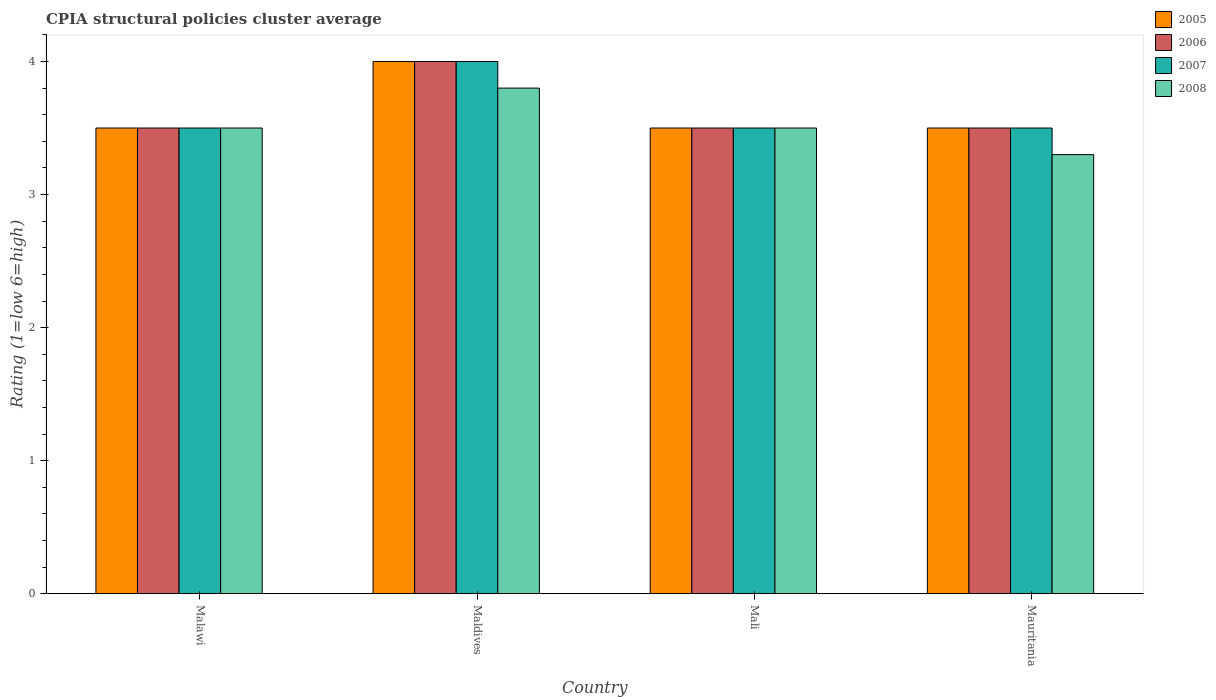How many different coloured bars are there?
Offer a terse response. 4. How many bars are there on the 3rd tick from the left?
Offer a very short reply. 4. How many bars are there on the 3rd tick from the right?
Ensure brevity in your answer.  4. What is the label of the 2nd group of bars from the left?
Offer a very short reply. Maldives. Across all countries, what is the minimum CPIA rating in 2008?
Your response must be concise. 3.3. In which country was the CPIA rating in 2006 maximum?
Provide a short and direct response. Maldives. In which country was the CPIA rating in 2005 minimum?
Offer a very short reply. Malawi. What is the total CPIA rating in 2008 in the graph?
Give a very brief answer. 14.1. What is the difference between the CPIA rating in 2008 in Malawi and that in Mauritania?
Provide a succinct answer. 0.2. What is the difference between the CPIA rating in 2005 in Maldives and the CPIA rating in 2006 in Mauritania?
Offer a very short reply. 0.5. What is the average CPIA rating in 2005 per country?
Keep it short and to the point. 3.62. What is the difference between the CPIA rating of/in 2008 and CPIA rating of/in 2005 in Maldives?
Keep it short and to the point. -0.2. What is the ratio of the CPIA rating in 2005 in Maldives to that in Mauritania?
Your answer should be compact. 1.14. Is the difference between the CPIA rating in 2008 in Maldives and Mauritania greater than the difference between the CPIA rating in 2005 in Maldives and Mauritania?
Make the answer very short. No. What is the difference between the highest and the second highest CPIA rating in 2007?
Provide a succinct answer. -0.5. In how many countries, is the CPIA rating in 2007 greater than the average CPIA rating in 2007 taken over all countries?
Your response must be concise. 1. Is the sum of the CPIA rating in 2008 in Maldives and Mauritania greater than the maximum CPIA rating in 2006 across all countries?
Ensure brevity in your answer.  Yes. Is it the case that in every country, the sum of the CPIA rating in 2006 and CPIA rating in 2005 is greater than the sum of CPIA rating in 2007 and CPIA rating in 2008?
Make the answer very short. No. What does the 2nd bar from the left in Mauritania represents?
Your answer should be very brief. 2006. What does the 2nd bar from the right in Maldives represents?
Keep it short and to the point. 2007. How many countries are there in the graph?
Provide a succinct answer. 4. What is the difference between two consecutive major ticks on the Y-axis?
Your answer should be compact. 1. Are the values on the major ticks of Y-axis written in scientific E-notation?
Provide a short and direct response. No. How many legend labels are there?
Your answer should be very brief. 4. How are the legend labels stacked?
Keep it short and to the point. Vertical. What is the title of the graph?
Provide a short and direct response. CPIA structural policies cluster average. What is the label or title of the X-axis?
Your answer should be compact. Country. What is the label or title of the Y-axis?
Your answer should be compact. Rating (1=low 6=high). What is the Rating (1=low 6=high) of 2005 in Malawi?
Keep it short and to the point. 3.5. What is the Rating (1=low 6=high) of 2007 in Malawi?
Your answer should be very brief. 3.5. What is the Rating (1=low 6=high) of 2008 in Malawi?
Provide a succinct answer. 3.5. What is the Rating (1=low 6=high) in 2005 in Maldives?
Offer a very short reply. 4. What is the Rating (1=low 6=high) of 2006 in Maldives?
Provide a succinct answer. 4. What is the Rating (1=low 6=high) in 2007 in Maldives?
Your answer should be compact. 4. What is the Rating (1=low 6=high) of 2006 in Mali?
Offer a terse response. 3.5. What is the Rating (1=low 6=high) in 2006 in Mauritania?
Your answer should be very brief. 3.5. Across all countries, what is the maximum Rating (1=low 6=high) in 2005?
Provide a short and direct response. 4. Across all countries, what is the minimum Rating (1=low 6=high) in 2008?
Keep it short and to the point. 3.3. What is the total Rating (1=low 6=high) of 2005 in the graph?
Keep it short and to the point. 14.5. What is the total Rating (1=low 6=high) of 2006 in the graph?
Provide a short and direct response. 14.5. What is the difference between the Rating (1=low 6=high) in 2006 in Malawi and that in Maldives?
Your answer should be very brief. -0.5. What is the difference between the Rating (1=low 6=high) in 2008 in Malawi and that in Maldives?
Your answer should be compact. -0.3. What is the difference between the Rating (1=low 6=high) in 2006 in Malawi and that in Mauritania?
Offer a very short reply. 0. What is the difference between the Rating (1=low 6=high) of 2007 in Maldives and that in Mali?
Make the answer very short. 0.5. What is the difference between the Rating (1=low 6=high) in 2005 in Maldives and that in Mauritania?
Give a very brief answer. 0.5. What is the difference between the Rating (1=low 6=high) of 2007 in Maldives and that in Mauritania?
Provide a short and direct response. 0.5. What is the difference between the Rating (1=low 6=high) in 2005 in Mali and that in Mauritania?
Your answer should be very brief. 0. What is the difference between the Rating (1=low 6=high) in 2008 in Mali and that in Mauritania?
Your response must be concise. 0.2. What is the difference between the Rating (1=low 6=high) in 2006 in Malawi and the Rating (1=low 6=high) in 2008 in Maldives?
Your response must be concise. -0.3. What is the difference between the Rating (1=low 6=high) in 2007 in Malawi and the Rating (1=low 6=high) in 2008 in Maldives?
Your answer should be very brief. -0.3. What is the difference between the Rating (1=low 6=high) of 2005 in Malawi and the Rating (1=low 6=high) of 2008 in Mali?
Your answer should be compact. 0. What is the difference between the Rating (1=low 6=high) in 2006 in Malawi and the Rating (1=low 6=high) in 2008 in Mali?
Give a very brief answer. 0. What is the difference between the Rating (1=low 6=high) of 2007 in Malawi and the Rating (1=low 6=high) of 2008 in Mali?
Your answer should be compact. 0. What is the difference between the Rating (1=low 6=high) in 2005 in Malawi and the Rating (1=low 6=high) in 2006 in Mauritania?
Provide a short and direct response. 0. What is the difference between the Rating (1=low 6=high) of 2006 in Malawi and the Rating (1=low 6=high) of 2007 in Mauritania?
Keep it short and to the point. 0. What is the difference between the Rating (1=low 6=high) of 2006 in Malawi and the Rating (1=low 6=high) of 2008 in Mauritania?
Provide a short and direct response. 0.2. What is the difference between the Rating (1=low 6=high) of 2005 in Maldives and the Rating (1=low 6=high) of 2006 in Mali?
Offer a very short reply. 0.5. What is the difference between the Rating (1=low 6=high) of 2005 in Maldives and the Rating (1=low 6=high) of 2007 in Mali?
Make the answer very short. 0.5. What is the difference between the Rating (1=low 6=high) in 2005 in Maldives and the Rating (1=low 6=high) in 2008 in Mali?
Offer a terse response. 0.5. What is the difference between the Rating (1=low 6=high) in 2006 in Maldives and the Rating (1=low 6=high) in 2007 in Mali?
Your response must be concise. 0.5. What is the difference between the Rating (1=low 6=high) in 2005 in Maldives and the Rating (1=low 6=high) in 2006 in Mauritania?
Offer a terse response. 0.5. What is the difference between the Rating (1=low 6=high) of 2005 in Maldives and the Rating (1=low 6=high) of 2008 in Mauritania?
Provide a succinct answer. 0.7. What is the difference between the Rating (1=low 6=high) in 2006 in Maldives and the Rating (1=low 6=high) in 2007 in Mauritania?
Provide a short and direct response. 0.5. What is the difference between the Rating (1=low 6=high) of 2007 in Maldives and the Rating (1=low 6=high) of 2008 in Mauritania?
Your answer should be very brief. 0.7. What is the difference between the Rating (1=low 6=high) in 2007 in Mali and the Rating (1=low 6=high) in 2008 in Mauritania?
Your answer should be compact. 0.2. What is the average Rating (1=low 6=high) in 2005 per country?
Offer a terse response. 3.62. What is the average Rating (1=low 6=high) of 2006 per country?
Your answer should be compact. 3.62. What is the average Rating (1=low 6=high) in 2007 per country?
Offer a terse response. 3.62. What is the average Rating (1=low 6=high) in 2008 per country?
Keep it short and to the point. 3.52. What is the difference between the Rating (1=low 6=high) in 2005 and Rating (1=low 6=high) in 2006 in Malawi?
Provide a short and direct response. 0. What is the difference between the Rating (1=low 6=high) of 2005 and Rating (1=low 6=high) of 2007 in Malawi?
Keep it short and to the point. 0. What is the difference between the Rating (1=low 6=high) in 2006 and Rating (1=low 6=high) in 2007 in Malawi?
Provide a short and direct response. 0. What is the difference between the Rating (1=low 6=high) in 2007 and Rating (1=low 6=high) in 2008 in Malawi?
Ensure brevity in your answer.  0. What is the difference between the Rating (1=low 6=high) of 2005 and Rating (1=low 6=high) of 2006 in Maldives?
Give a very brief answer. 0. What is the difference between the Rating (1=low 6=high) in 2005 and Rating (1=low 6=high) in 2007 in Maldives?
Provide a short and direct response. 0. What is the difference between the Rating (1=low 6=high) in 2005 and Rating (1=low 6=high) in 2008 in Maldives?
Your answer should be compact. 0.2. What is the difference between the Rating (1=low 6=high) of 2006 and Rating (1=low 6=high) of 2007 in Maldives?
Ensure brevity in your answer.  0. What is the difference between the Rating (1=low 6=high) of 2005 and Rating (1=low 6=high) of 2006 in Mali?
Keep it short and to the point. 0. What is the difference between the Rating (1=low 6=high) in 2005 and Rating (1=low 6=high) in 2007 in Mali?
Your answer should be very brief. 0. What is the difference between the Rating (1=low 6=high) of 2007 and Rating (1=low 6=high) of 2008 in Mali?
Give a very brief answer. 0. What is the difference between the Rating (1=low 6=high) in 2005 and Rating (1=low 6=high) in 2006 in Mauritania?
Provide a succinct answer. 0. What is the difference between the Rating (1=low 6=high) in 2005 and Rating (1=low 6=high) in 2007 in Mauritania?
Offer a terse response. 0. What is the difference between the Rating (1=low 6=high) of 2005 and Rating (1=low 6=high) of 2008 in Mauritania?
Provide a short and direct response. 0.2. What is the difference between the Rating (1=low 6=high) in 2006 and Rating (1=low 6=high) in 2007 in Mauritania?
Offer a very short reply. 0. What is the ratio of the Rating (1=low 6=high) in 2005 in Malawi to that in Maldives?
Offer a terse response. 0.88. What is the ratio of the Rating (1=low 6=high) in 2008 in Malawi to that in Maldives?
Make the answer very short. 0.92. What is the ratio of the Rating (1=low 6=high) of 2007 in Malawi to that in Mali?
Offer a terse response. 1. What is the ratio of the Rating (1=low 6=high) in 2008 in Malawi to that in Mali?
Keep it short and to the point. 1. What is the ratio of the Rating (1=low 6=high) in 2006 in Malawi to that in Mauritania?
Your response must be concise. 1. What is the ratio of the Rating (1=low 6=high) in 2007 in Malawi to that in Mauritania?
Ensure brevity in your answer.  1. What is the ratio of the Rating (1=low 6=high) in 2008 in Malawi to that in Mauritania?
Make the answer very short. 1.06. What is the ratio of the Rating (1=low 6=high) of 2005 in Maldives to that in Mali?
Your answer should be very brief. 1.14. What is the ratio of the Rating (1=low 6=high) of 2006 in Maldives to that in Mali?
Your response must be concise. 1.14. What is the ratio of the Rating (1=low 6=high) of 2008 in Maldives to that in Mali?
Ensure brevity in your answer.  1.09. What is the ratio of the Rating (1=low 6=high) in 2006 in Maldives to that in Mauritania?
Give a very brief answer. 1.14. What is the ratio of the Rating (1=low 6=high) of 2008 in Maldives to that in Mauritania?
Offer a very short reply. 1.15. What is the ratio of the Rating (1=low 6=high) of 2006 in Mali to that in Mauritania?
Your response must be concise. 1. What is the ratio of the Rating (1=low 6=high) of 2007 in Mali to that in Mauritania?
Provide a short and direct response. 1. What is the ratio of the Rating (1=low 6=high) in 2008 in Mali to that in Mauritania?
Give a very brief answer. 1.06. What is the difference between the highest and the second highest Rating (1=low 6=high) of 2005?
Provide a succinct answer. 0.5. What is the difference between the highest and the second highest Rating (1=low 6=high) of 2007?
Provide a short and direct response. 0.5. What is the difference between the highest and the lowest Rating (1=low 6=high) of 2005?
Your answer should be compact. 0.5. What is the difference between the highest and the lowest Rating (1=low 6=high) of 2006?
Offer a terse response. 0.5. 